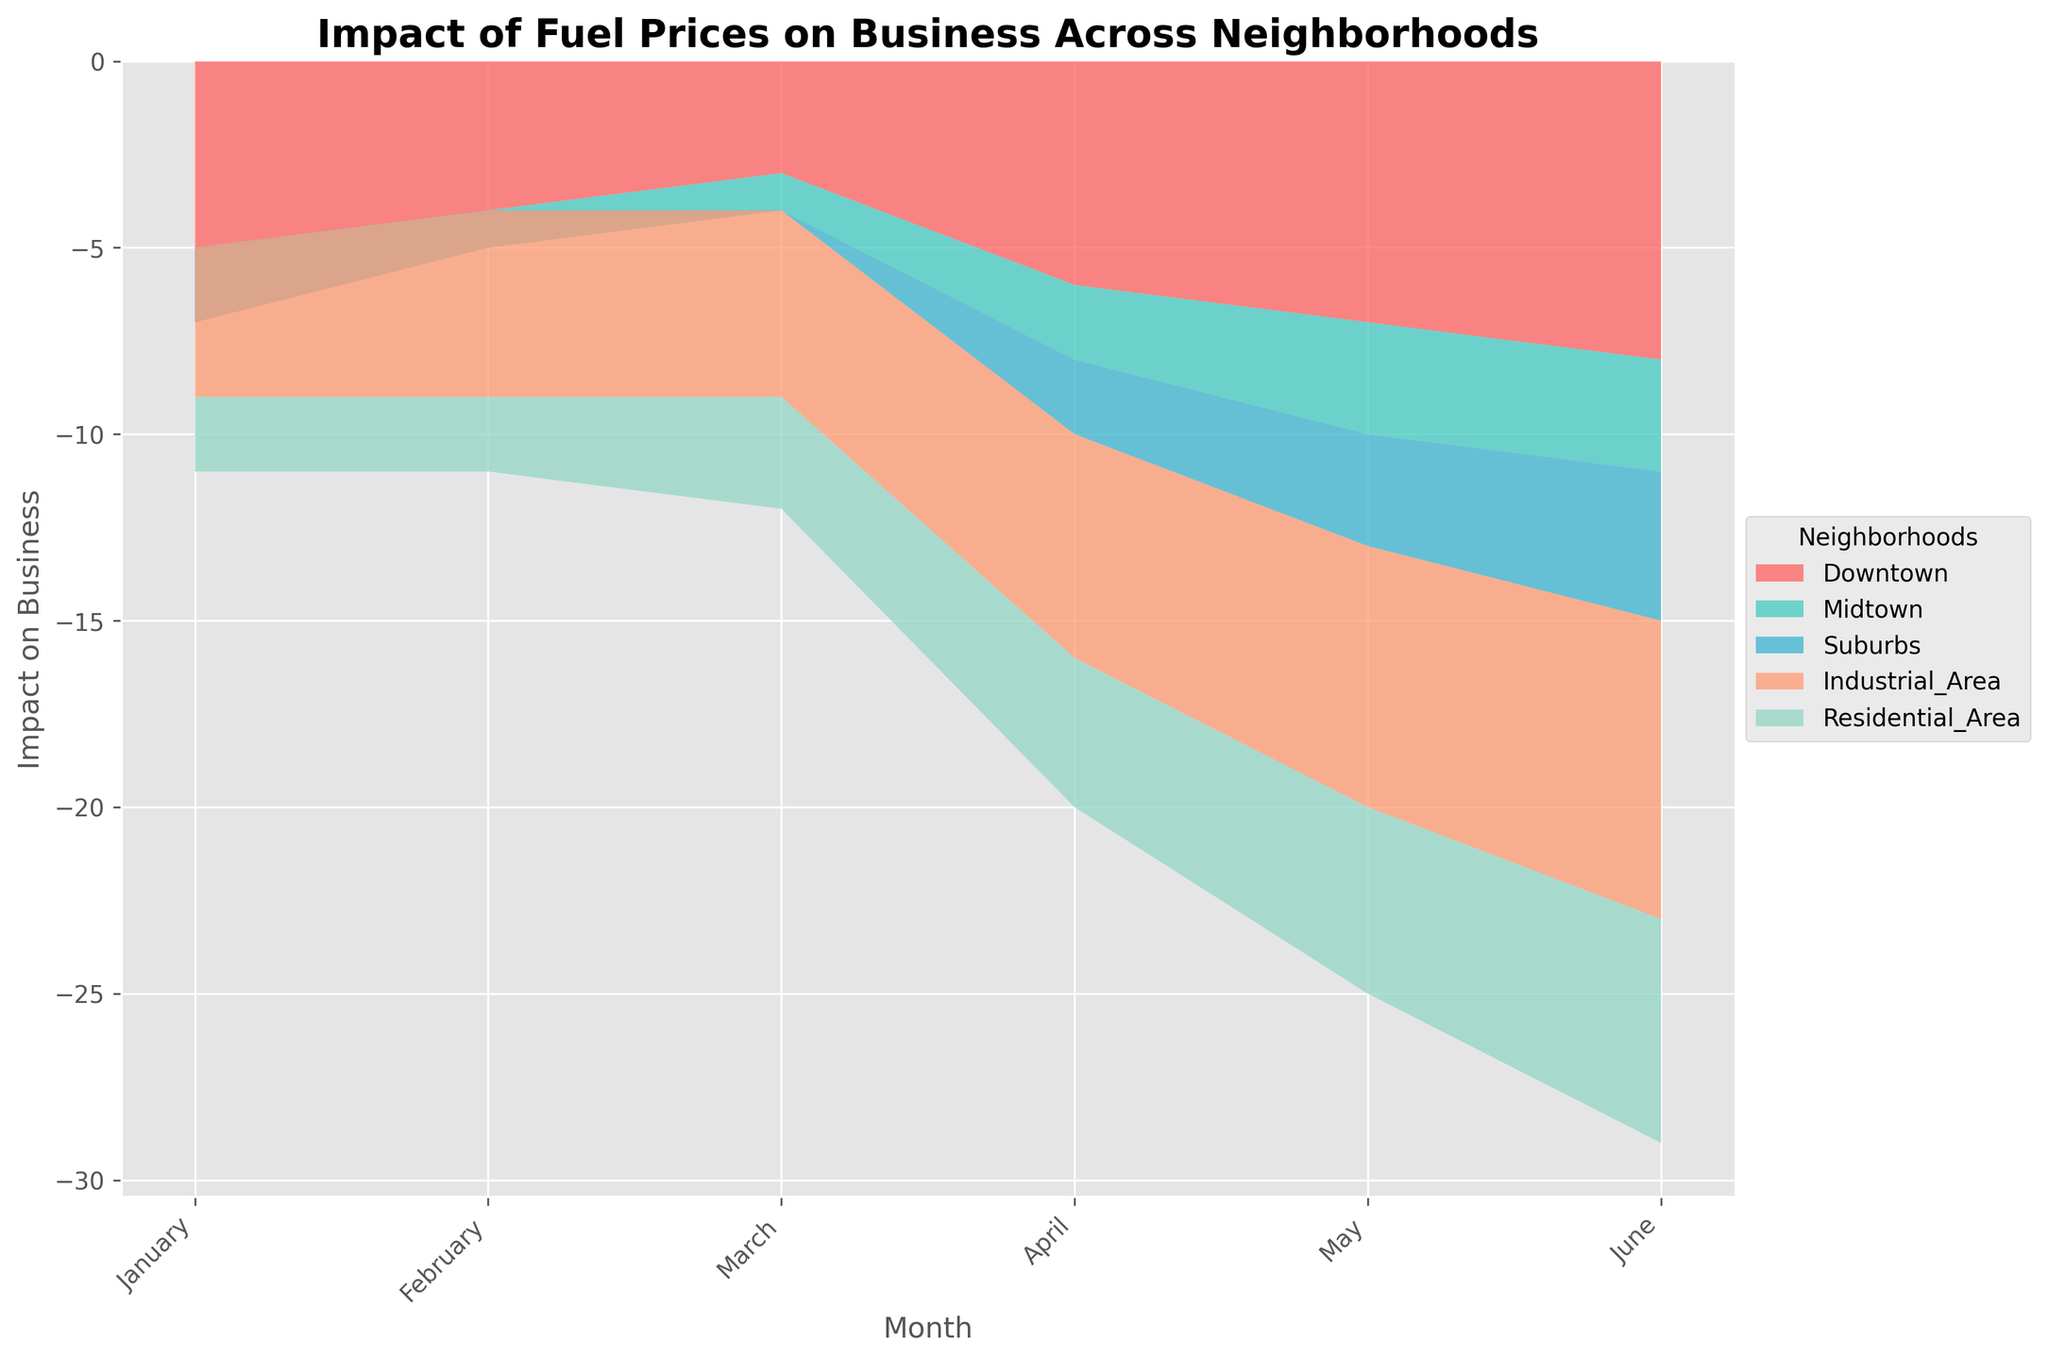What is the title of the figure? The title is usually located at the top of the figure. By looking at the top, we can see it reads "Impact of Fuel Prices on Business Across Neighborhoods."
Answer: Impact of Fuel Prices on Business Across Neighborhoods Which neighborhood has the most negative impact in June? To find this, look at the end (June) and identify the neighborhood layer that dips the most. The bottom layer, representing Downtown, shows the most negative impact.
Answer: Downtown How does the impact on business in the Suburbs change from January to June? Identify the Suburbs layer and follow its trend from January to June. The impact starts positive in January (+2), decreases to +1, then to 0, and continuously declines to -4 in June.
Answer: Decreases What are the colors used to represent the neighborhoods? Identify the color associated with each neighborhood by looking at the legend. The colors are represented as shades: Downtown is reddish, Midtown is greenish, Suburbs are cyan-like, Industrial Area is salmon-like, and Residential Area is light teal.
Answer: Reddish, greenish, cyan-like, salmon-like, light teal Which neighborhood had a stable impact with little fluctuation? Look at the layers that do not show significant changes month-to-month. The Midtown layer shows minor fluctuations (between -1 to -3), indicating more stability.
Answer: Midtown What month does Downtown experience the steepest decline in its impact on business? Look for the month where the Downtown layer drops sharply. The steepest decline is between May and June.
Answer: May to June Which neighborhood shows a positive impact at any point during the months? Scan through each month to see any positive values in a layer. The Suburbs show a positive impact in January (+2), February (+1), and March (0).
Answer: Suburbs Compare the impact on business for Residential Area and Industrial Area in April. Find the corresponding points for both neighborhoods in April. Residential Area has an impact of -4, while Industrial Area is at -6.
Answer: Residential Area: -4, Industrial Area: -6 How many neighborhoods experienced a negative impact in February? Look at the levels in February and count the ones below zero. Downtown (-4), Industrial Area (-5), and Residential Area (-2) experienced negative impacts.
Answer: Three neighborhoods Which neighborhood shows the most significant decline from January to June? Calculate the difference in impact from January to June for each neighborhood. Downtown drops from -5 to -8 (change of -3), Midtown from -2 to -3 (change of -1), Suburbs from +2 to -4 (change of -6), Industrial Area from -4 to -8 (change of -4), and Residential Area from -2 to -6 (change of -4). The Suburbs show the most significant decline of 6 points.
Answer: Suburbs 